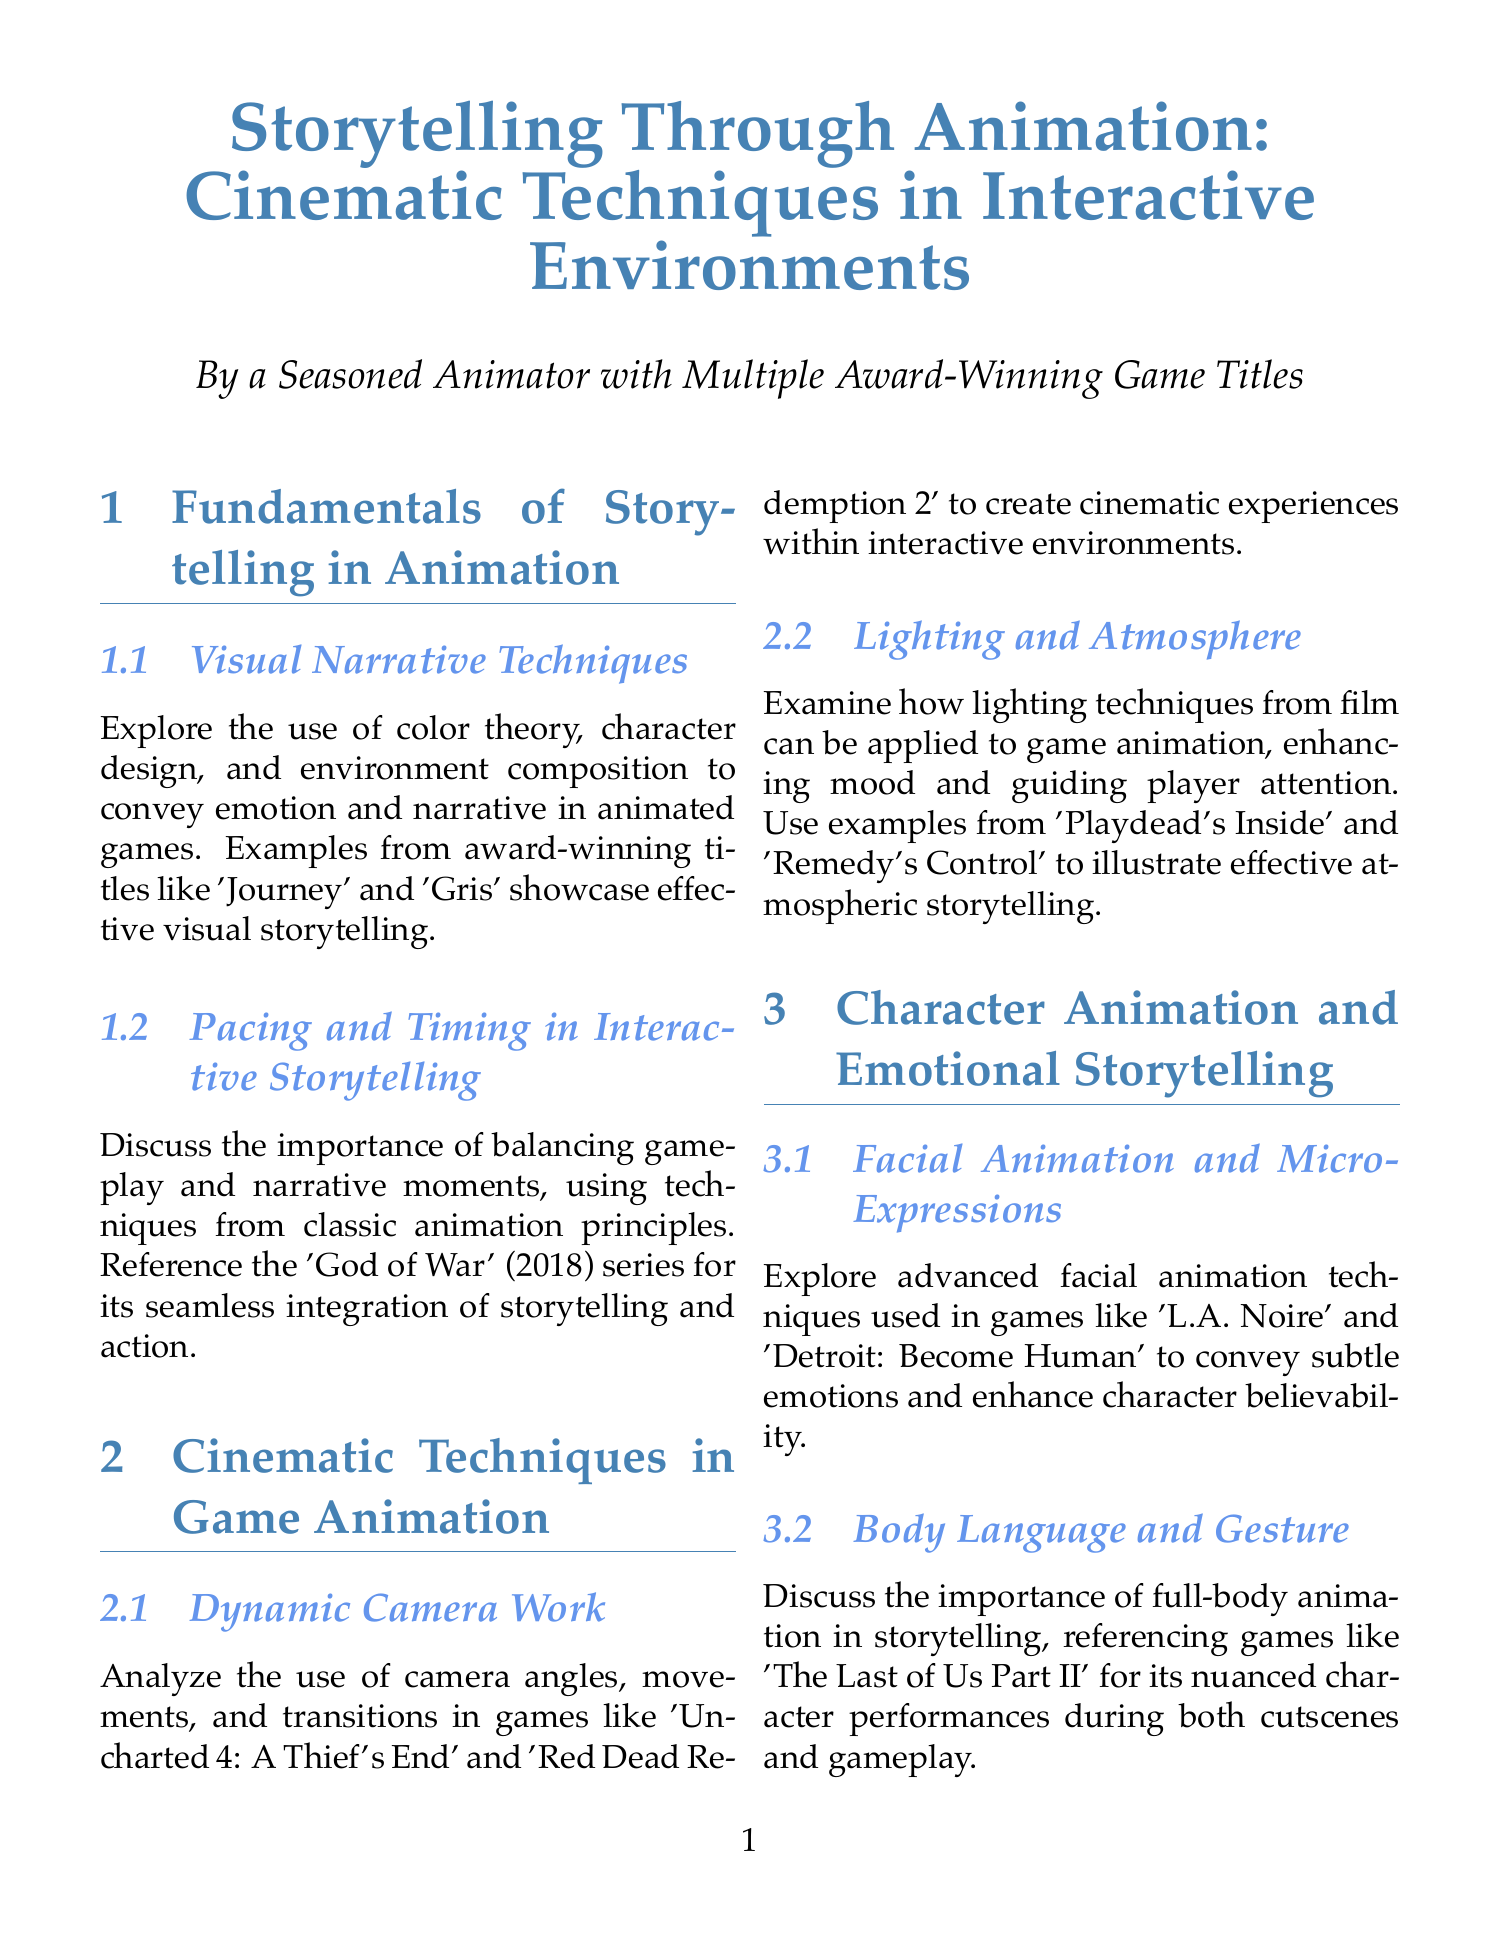What are visual narrative techniques? Visual narrative techniques include color theory, character design, and environment composition to convey emotion and narrative in animated games.
Answer: Color theory, character design, environment composition Which game series is referenced for pacing and timing in interactive storytelling? The document references the 'God of War' (2018) series to illustrate pacing and timing in storytelling.
Answer: God of War (2018) What is discussed in the section on dynamic camera work? The section on dynamic camera work analyzes the use of camera angles, movements, and transitions in games.
Answer: Camera angles, movements, transitions Which games are used as examples for facial animation techniques? The examples provided for facial animation techniques are 'L.A. Noire' and 'Detroit: Become Human'.
Answer: L.A. Noire, Detroit: Become Human What is the focus of the subsection on world-building? The focus of the world-building subsection is to analyze how animated elements can tell stories without dialogue.
Answer: Animated elements without dialogue What emerging technology is discussed for future storytelling techniques? The manual discusses VR and AR storytelling techniques as emerging technologies for future storytelling.
Answer: VR and AR What does the section on AI-driven narrative animation explore? The section on AI-driven narrative animation explores the potential of AI-generated animations for dynamic storytelling in games.
Answer: AI-generated animations Which game is referenced for motion capture integration? The document references 'Hellblade: Senua's Sacrifice' for its use of motion capture technology in storytelling.
Answer: Hellblade: Senua's Sacrifice What character performance aspect is highlighted in 'The Last of Us Part II'? The character performance aspect highlighted in 'The Last of Us Part II' is full-body animation during cutscenes and gameplay.
Answer: Full-body animation 